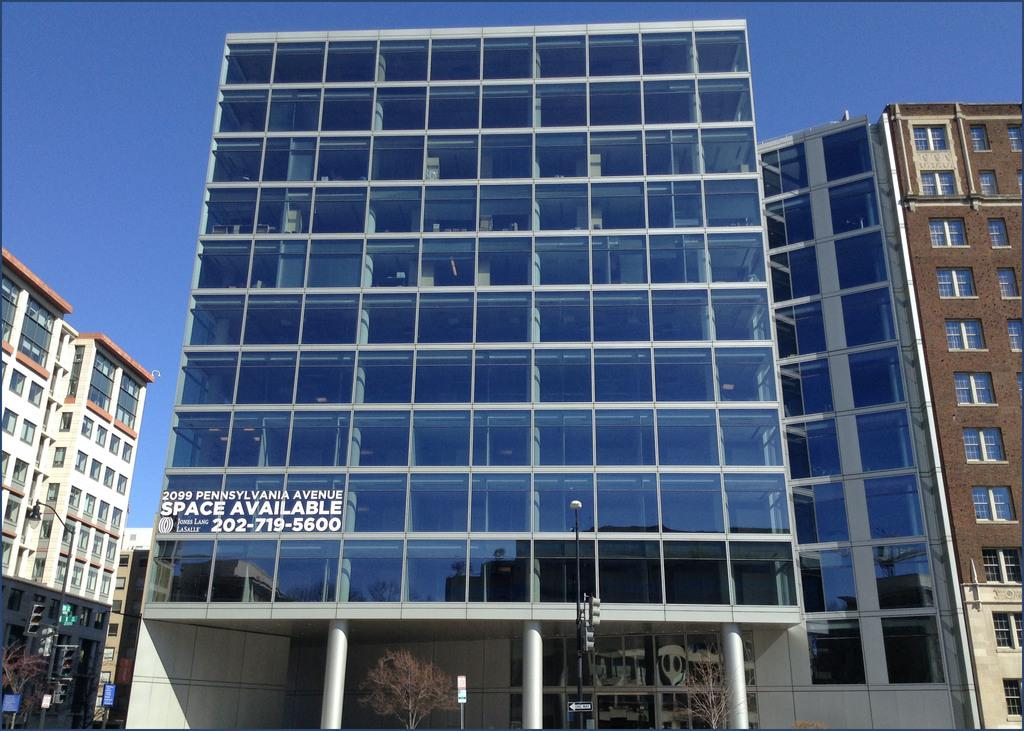What type of structures are present in the image? There are residential buildings in the image. Can you describe the condition of one of the buildings? One of the buildings appears to be empty. What can be seen in the background of the image? The sky is visible in the background of the image. How many goldfish can be seen swimming in the empty building? There are no goldfish present in the image, as it features residential buildings and a sky background. 